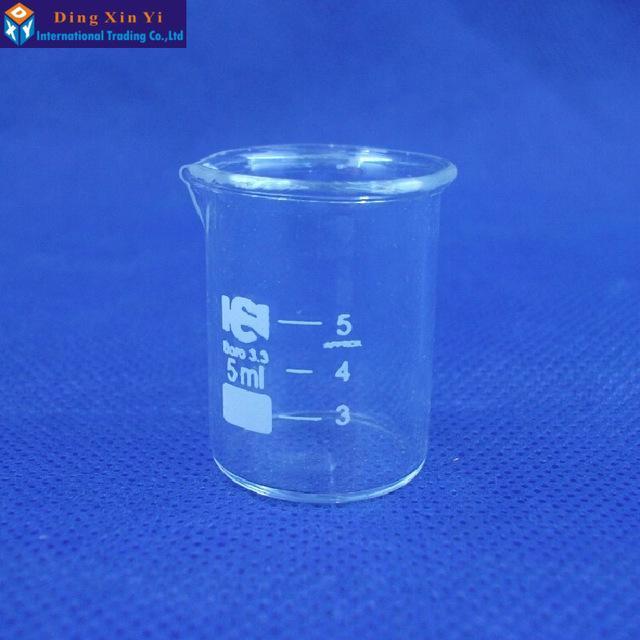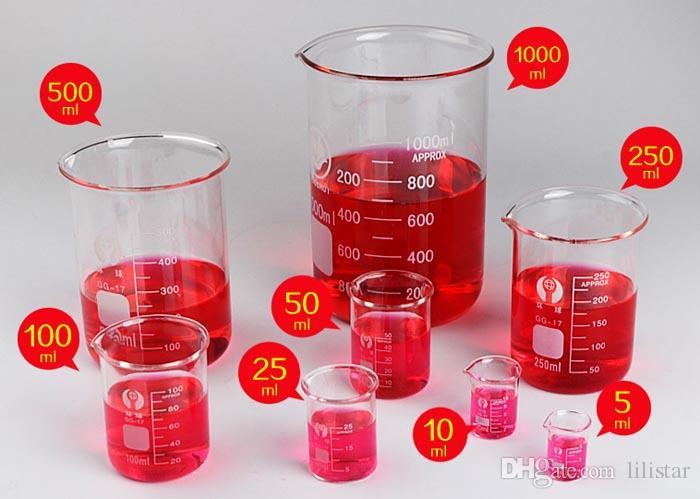The first image is the image on the left, the second image is the image on the right. Given the left and right images, does the statement "There is green liquid in both images." hold true? Answer yes or no. No. The first image is the image on the left, the second image is the image on the right. Examine the images to the left and right. Is the description "There is no less than 14 filled beakers." accurate? Answer yes or no. No. 